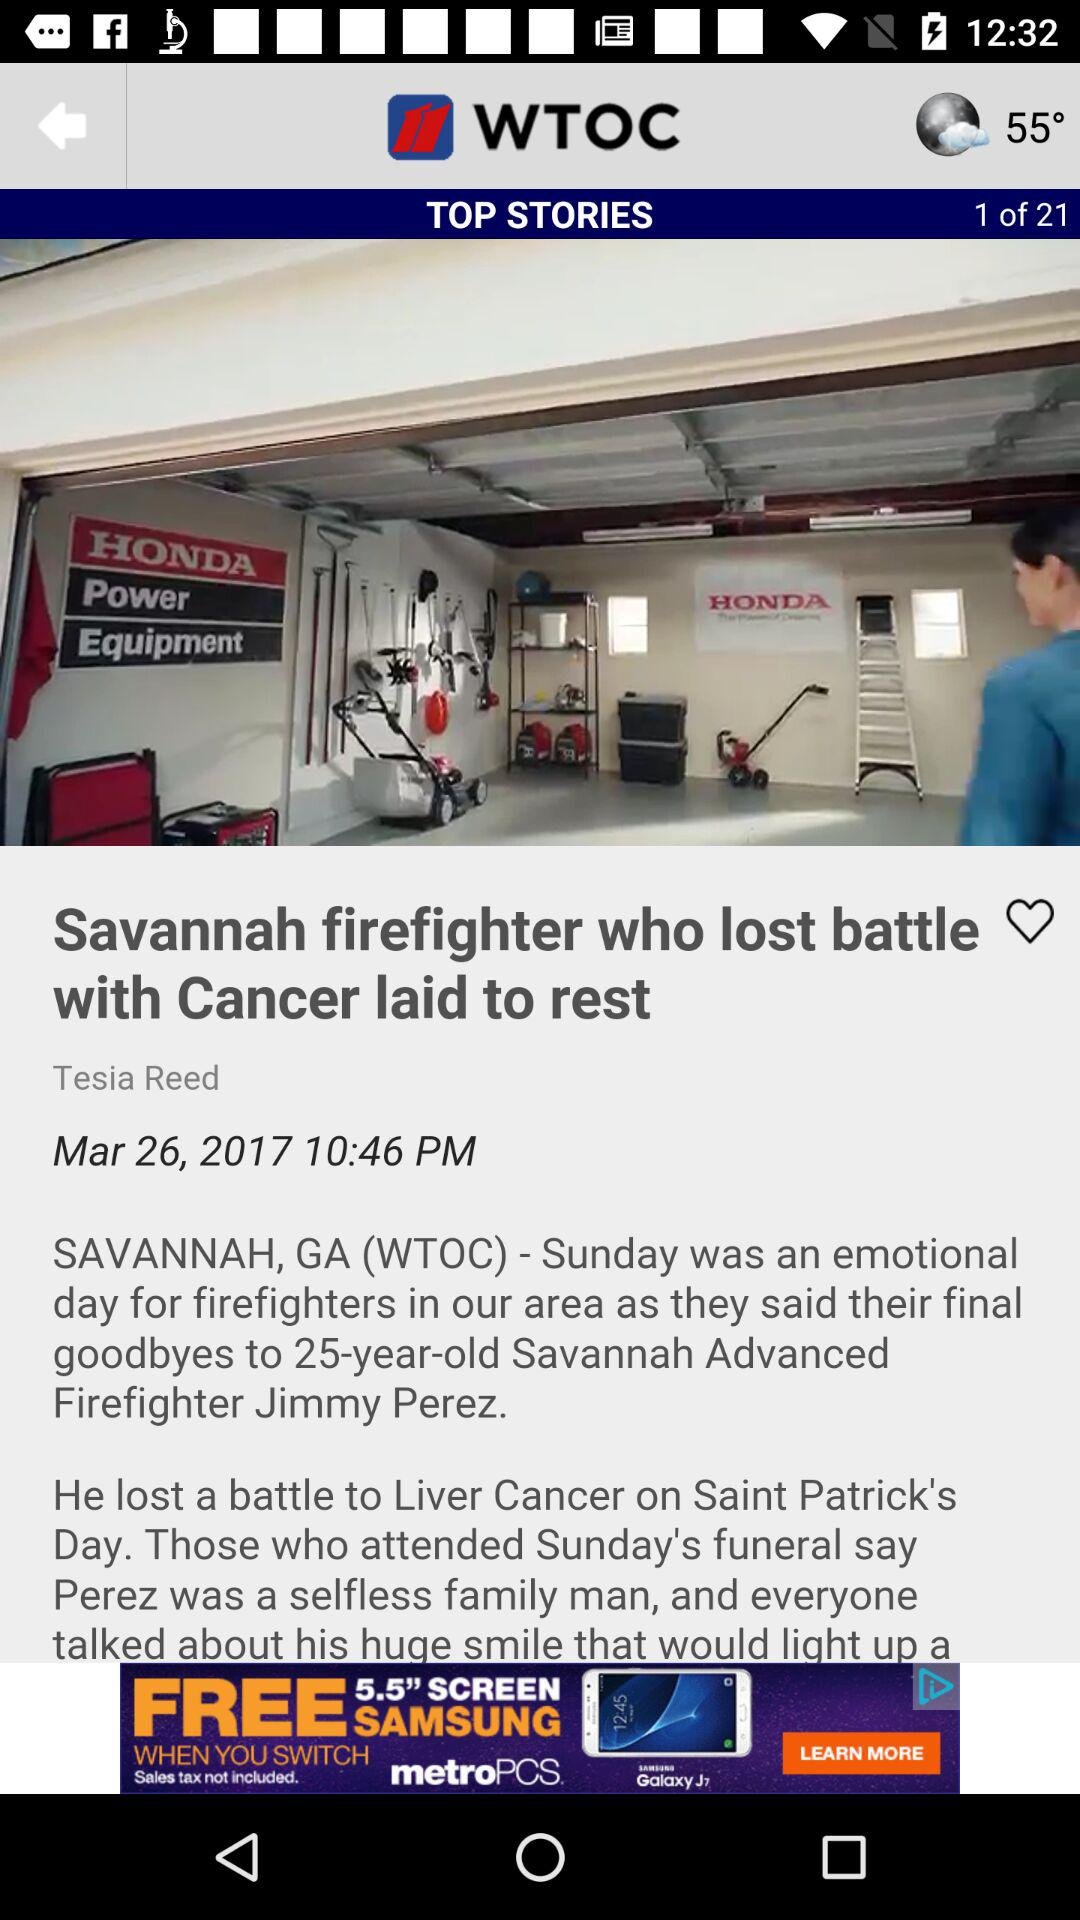Currently we are on which page number? Currently, you are on page number 1. 